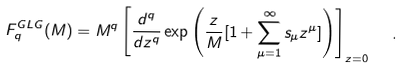Convert formula to latex. <formula><loc_0><loc_0><loc_500><loc_500>F _ { q } ^ { G L G } ( M ) = M ^ { q } \left [ \frac { d ^ { q } } { d z ^ { q } } \exp { \left ( \frac { z } { M } [ 1 + \sum _ { \mu = 1 } ^ { \infty } s _ { \mu } z ^ { \mu } ] \right ) } \right ] _ { z = 0 } \ \ .</formula> 